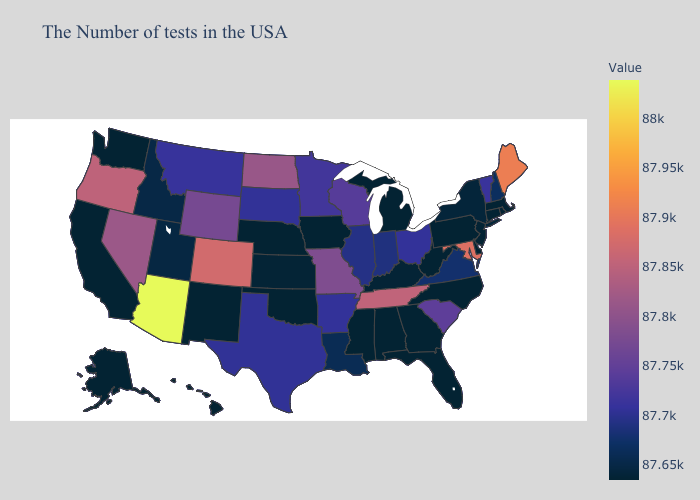Does Connecticut have the highest value in the USA?
Short answer required. No. Among the states that border Mississippi , which have the highest value?
Answer briefly. Tennessee. Does Massachusetts have the lowest value in the USA?
Quick response, please. Yes. Which states have the lowest value in the MidWest?
Be succinct. Michigan, Iowa, Nebraska. Which states have the lowest value in the West?
Be succinct. New Mexico, California, Washington, Alaska, Hawaii. Which states have the lowest value in the MidWest?
Quick response, please. Michigan, Iowa, Nebraska. 